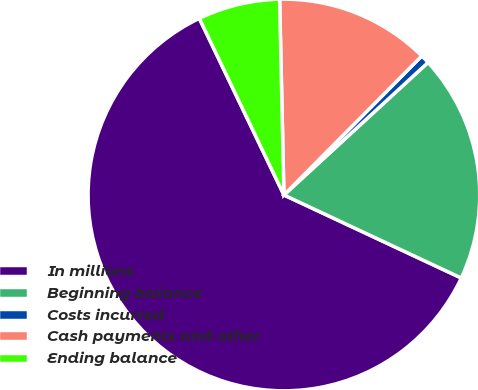Convert chart to OTSL. <chart><loc_0><loc_0><loc_500><loc_500><pie_chart><fcel>In millions<fcel>Beginning balance<fcel>Costs incurred<fcel>Cash payments and other<fcel>Ending balance<nl><fcel>60.93%<fcel>18.8%<fcel>0.74%<fcel>12.78%<fcel>6.76%<nl></chart> 